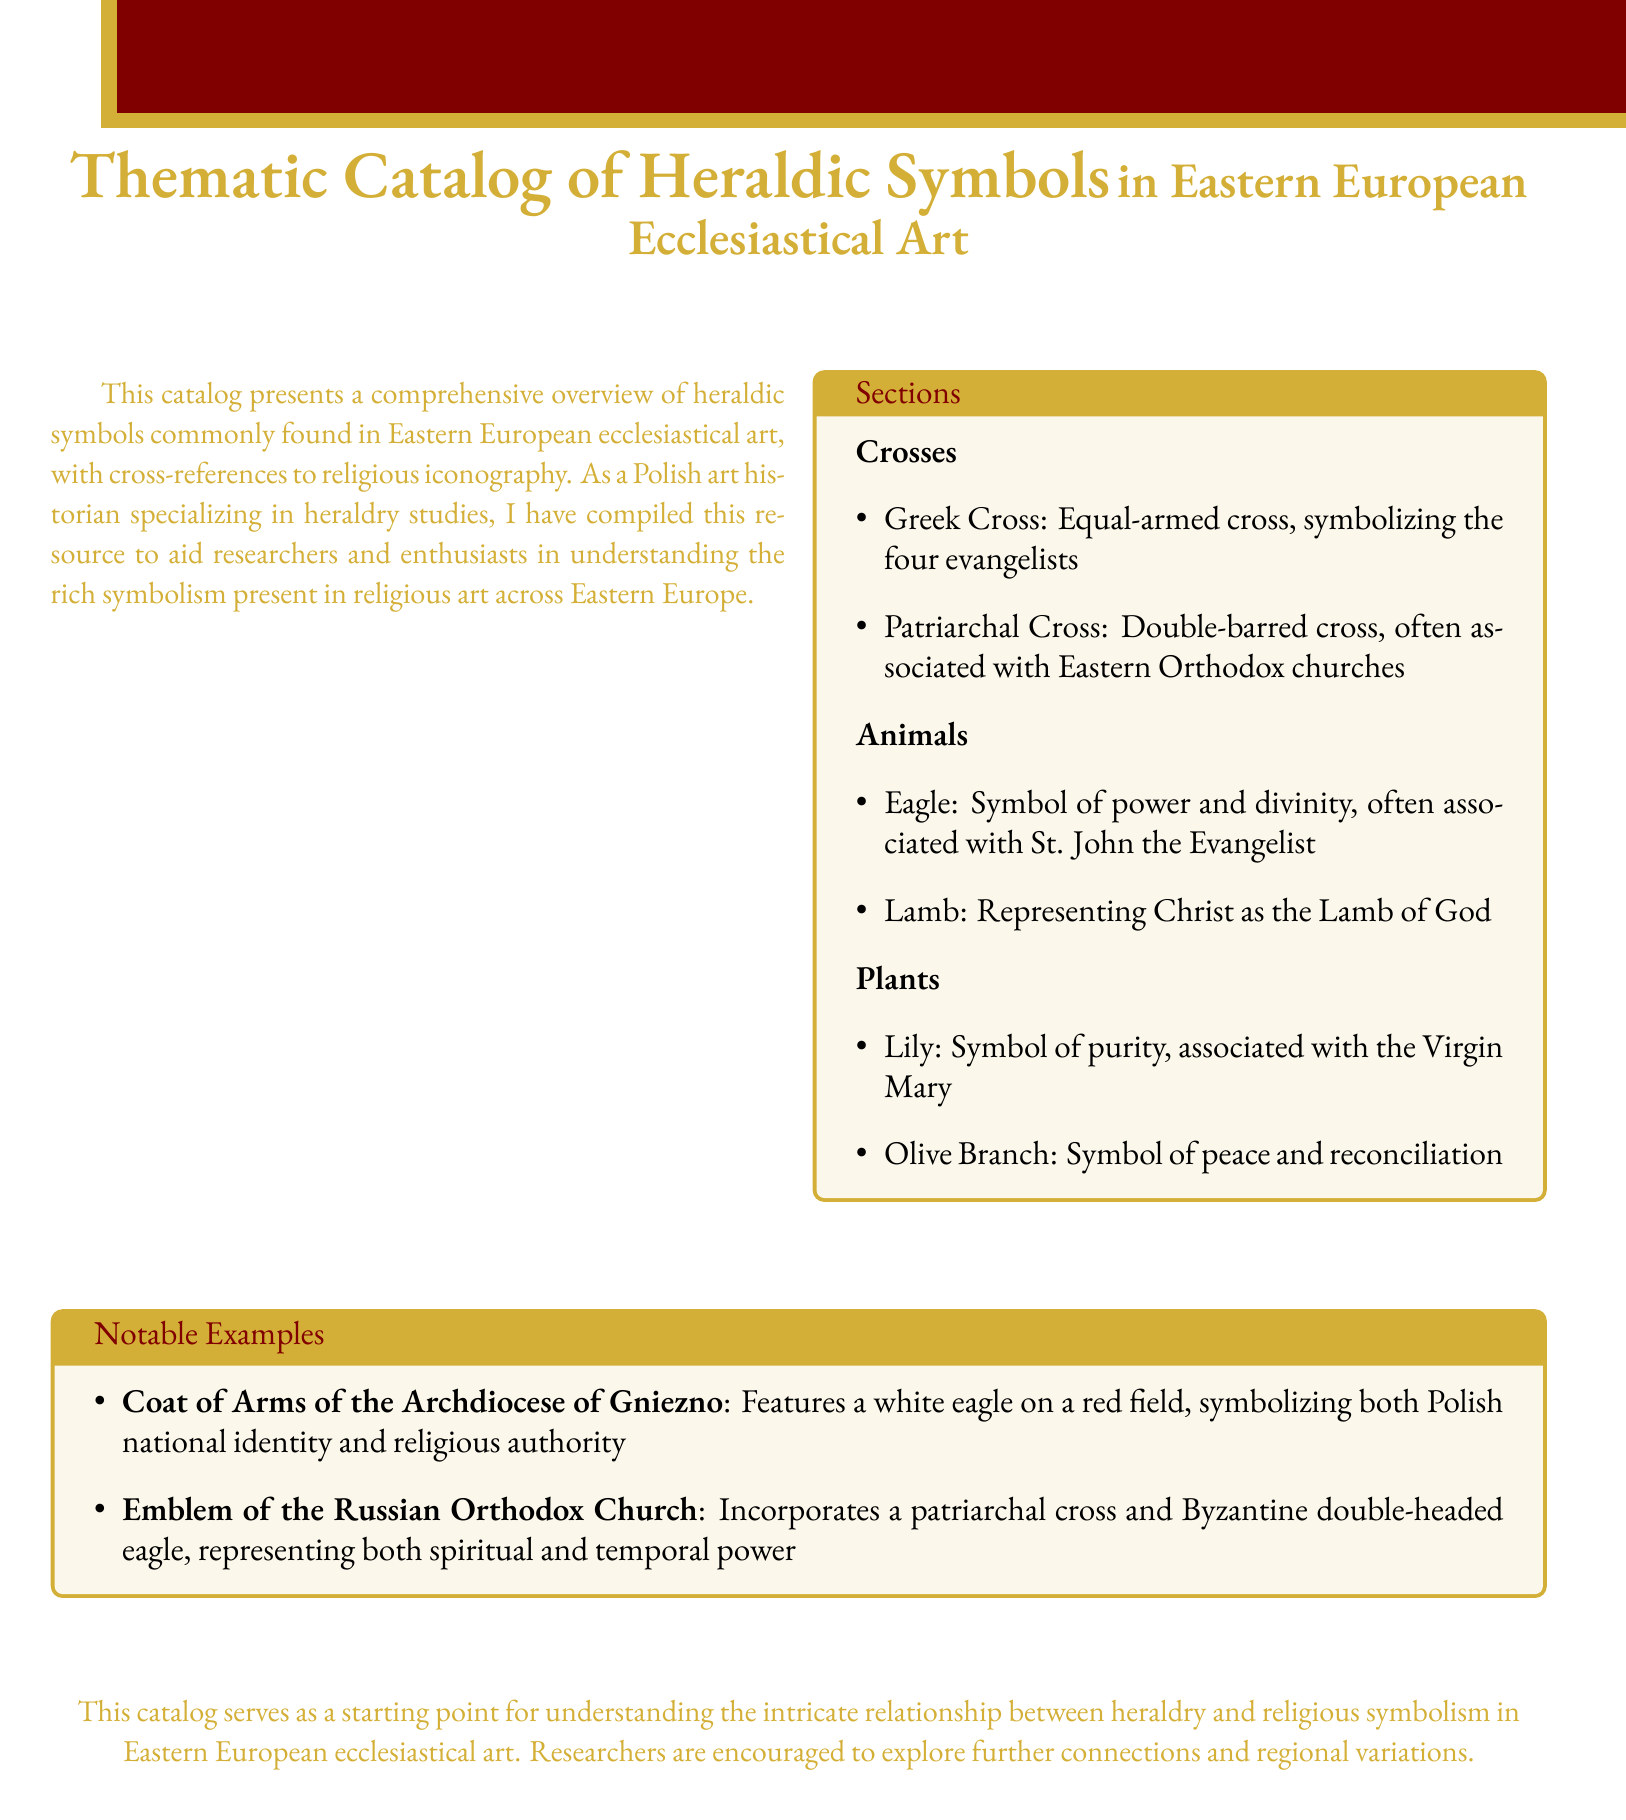what is the title of the catalog? The title of the catalog is presented prominently at the top of the document, indicating its focus on heraldic symbols in a specific context.
Answer: Thematic Catalog of Heraldic Symbols in Eastern European Ecclesiastical Art how many sections are listed in the catalog? The catalog includes a section titled "Sections" which details various heraldic elements under different categories.
Answer: Three what does the Greek Cross symbolize? The symbolism of the Greek Cross is defined in the "Crosses" section of the catalog, indicating its significance within religious contexts.
Answer: The four evangelists which animal is associated with St. John the Evangelist? In the "Animals" section, the catalog directly links specific animals with their historical and religious significance.
Answer: Eagle what does the olive branch symbolize? The "Plants" section describes various plants and their meanings within ecclesiastical art, providing insight into their symbolic value.
Answer: Peace and reconciliation which archdiocese's coat of arms is mentioned? The catalog specifically notes the "Coat of Arms of the Archdiocese of Gniezno" as a notable example in heraldic symbolism.
Answer: Archdiocese of Gniezno what emblem is noted for the Russian Orthodox Church? The document lists the emblem associated with the Russian Orthodox Church as part of the notable examples, highlighting its elements.
Answer: Emblem of the Russian Orthodox Church which flower is associated with the Virgin Mary? The catalog mentions specific plants and their relations to religious figures, noting the significance of the lily.
Answer: Lily 